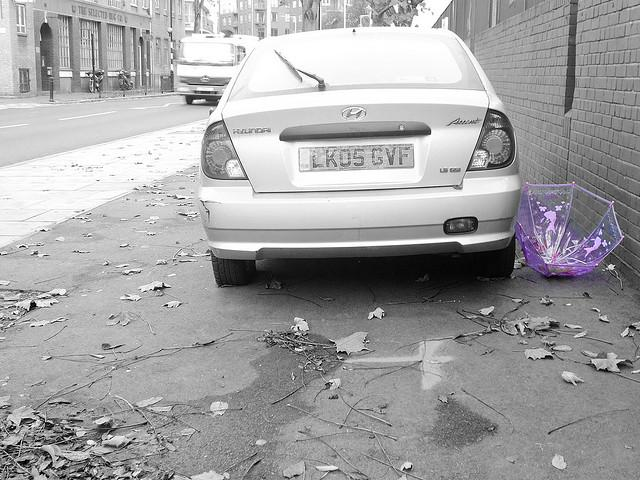What is this model of car called in South Korea?

Choices:
A) hyundai verna
B) hyundai tucson
C) hyundai minho
D) hyundai kia hyundai verna 